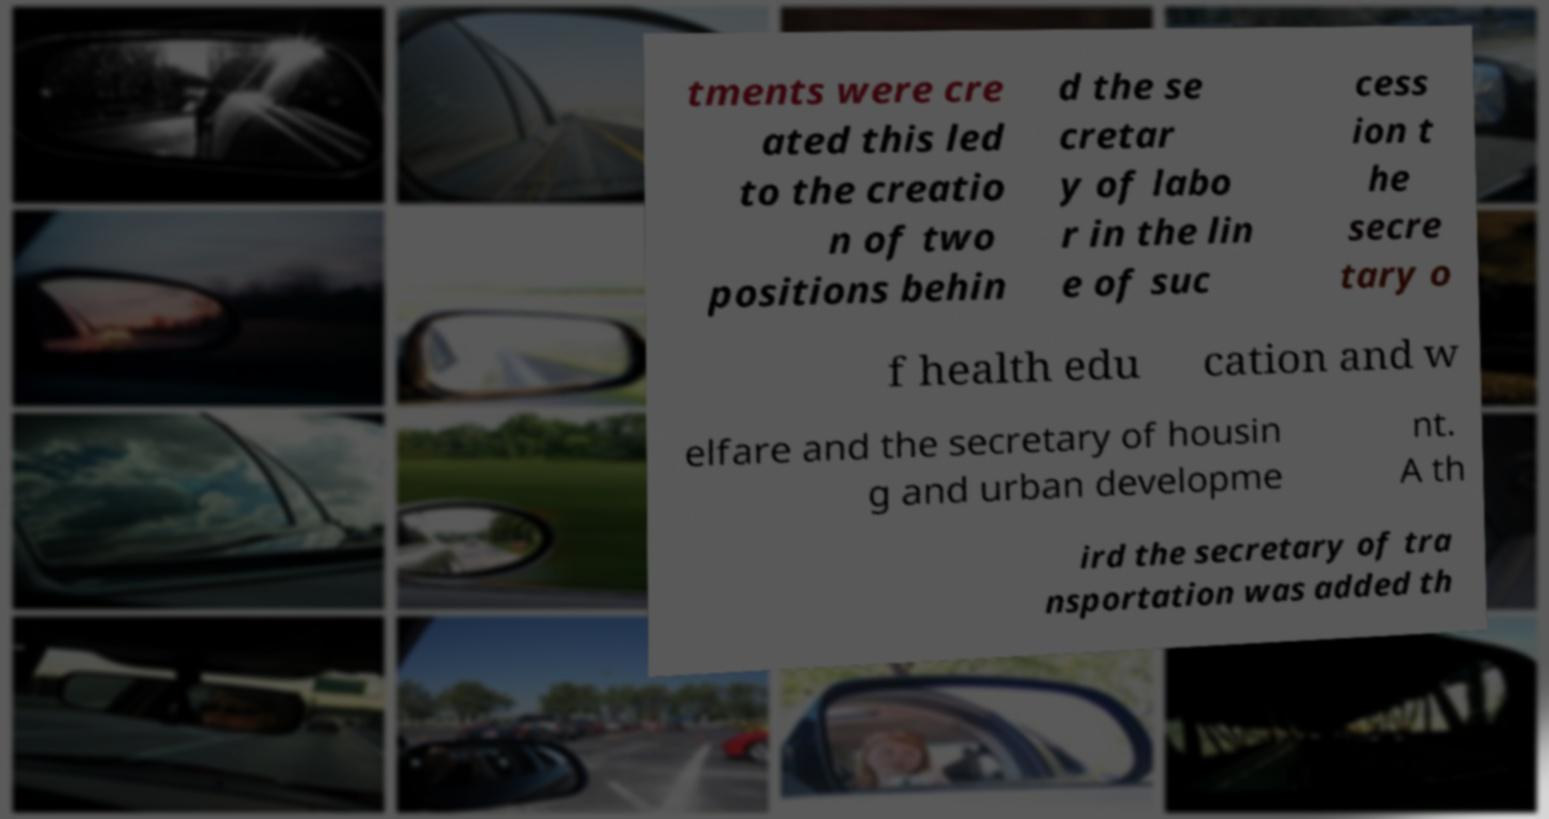Please read and relay the text visible in this image. What does it say? tments were cre ated this led to the creatio n of two positions behin d the se cretar y of labo r in the lin e of suc cess ion t he secre tary o f health edu cation and w elfare and the secretary of housin g and urban developme nt. A th ird the secretary of tra nsportation was added th 